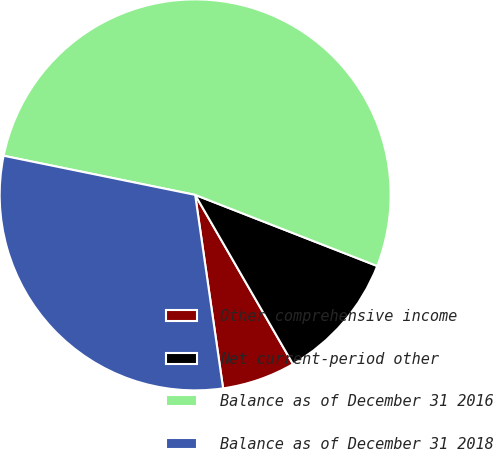<chart> <loc_0><loc_0><loc_500><loc_500><pie_chart><fcel>Other comprehensive income<fcel>Net current-period other<fcel>Balance as of December 31 2016<fcel>Balance as of December 31 2018<nl><fcel>6.06%<fcel>10.73%<fcel>52.72%<fcel>30.49%<nl></chart> 